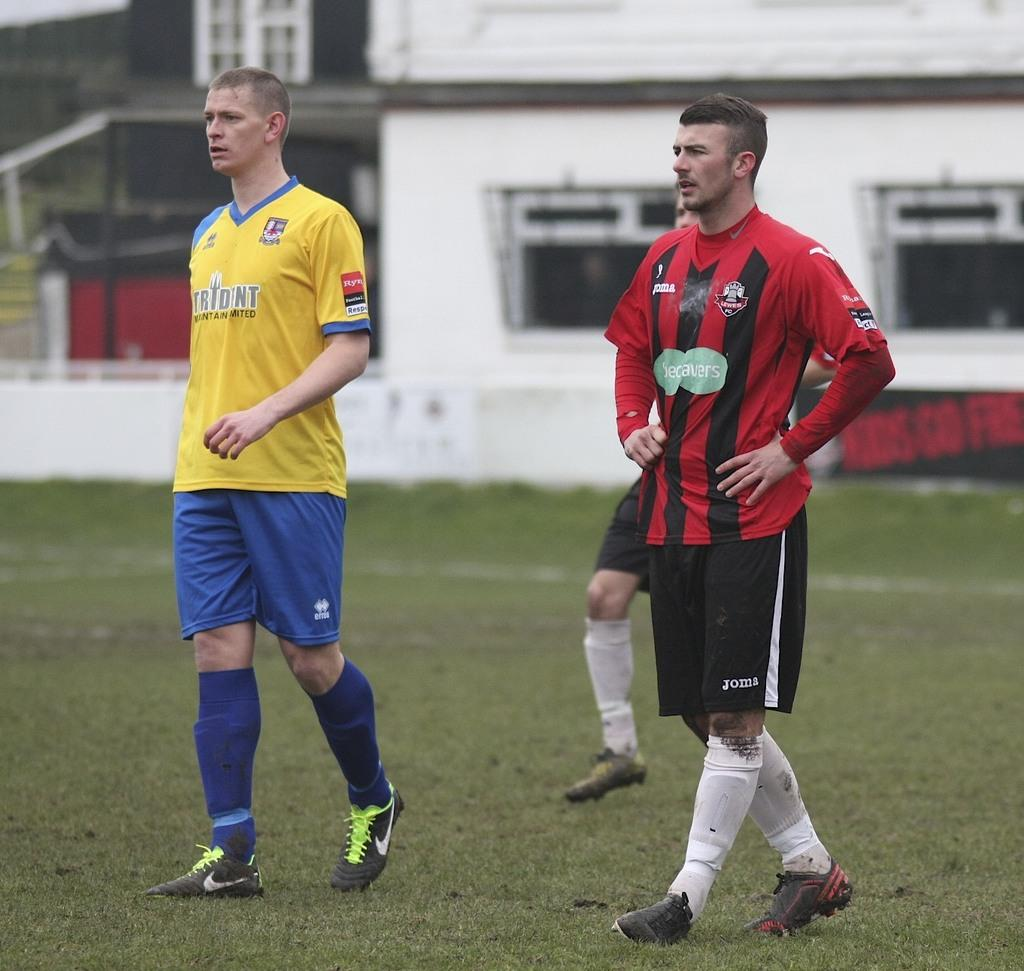<image>
Present a compact description of the photo's key features. Two soccer players one in yellow jersey that says Tridentand another in red that says becavers 